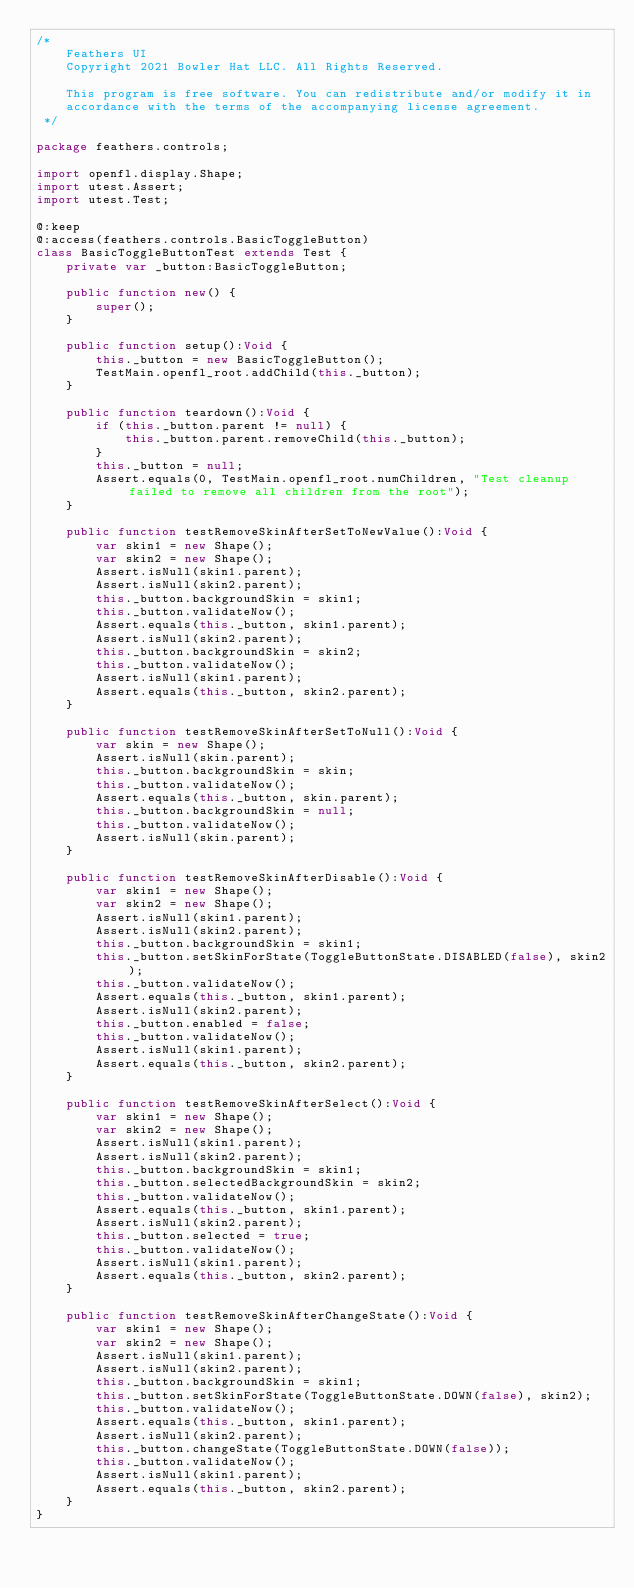<code> <loc_0><loc_0><loc_500><loc_500><_Haxe_>/*
	Feathers UI
	Copyright 2021 Bowler Hat LLC. All Rights Reserved.

	This program is free software. You can redistribute and/or modify it in
	accordance with the terms of the accompanying license agreement.
 */

package feathers.controls;

import openfl.display.Shape;
import utest.Assert;
import utest.Test;

@:keep
@:access(feathers.controls.BasicToggleButton)
class BasicToggleButtonTest extends Test {
	private var _button:BasicToggleButton;

	public function new() {
		super();
	}

	public function setup():Void {
		this._button = new BasicToggleButton();
		TestMain.openfl_root.addChild(this._button);
	}

	public function teardown():Void {
		if (this._button.parent != null) {
			this._button.parent.removeChild(this._button);
		}
		this._button = null;
		Assert.equals(0, TestMain.openfl_root.numChildren, "Test cleanup failed to remove all children from the root");
	}

	public function testRemoveSkinAfterSetToNewValue():Void {
		var skin1 = new Shape();
		var skin2 = new Shape();
		Assert.isNull(skin1.parent);
		Assert.isNull(skin2.parent);
		this._button.backgroundSkin = skin1;
		this._button.validateNow();
		Assert.equals(this._button, skin1.parent);
		Assert.isNull(skin2.parent);
		this._button.backgroundSkin = skin2;
		this._button.validateNow();
		Assert.isNull(skin1.parent);
		Assert.equals(this._button, skin2.parent);
	}

	public function testRemoveSkinAfterSetToNull():Void {
		var skin = new Shape();
		Assert.isNull(skin.parent);
		this._button.backgroundSkin = skin;
		this._button.validateNow();
		Assert.equals(this._button, skin.parent);
		this._button.backgroundSkin = null;
		this._button.validateNow();
		Assert.isNull(skin.parent);
	}

	public function testRemoveSkinAfterDisable():Void {
		var skin1 = new Shape();
		var skin2 = new Shape();
		Assert.isNull(skin1.parent);
		Assert.isNull(skin2.parent);
		this._button.backgroundSkin = skin1;
		this._button.setSkinForState(ToggleButtonState.DISABLED(false), skin2);
		this._button.validateNow();
		Assert.equals(this._button, skin1.parent);
		Assert.isNull(skin2.parent);
		this._button.enabled = false;
		this._button.validateNow();
		Assert.isNull(skin1.parent);
		Assert.equals(this._button, skin2.parent);
	}

	public function testRemoveSkinAfterSelect():Void {
		var skin1 = new Shape();
		var skin2 = new Shape();
		Assert.isNull(skin1.parent);
		Assert.isNull(skin2.parent);
		this._button.backgroundSkin = skin1;
		this._button.selectedBackgroundSkin = skin2;
		this._button.validateNow();
		Assert.equals(this._button, skin1.parent);
		Assert.isNull(skin2.parent);
		this._button.selected = true;
		this._button.validateNow();
		Assert.isNull(skin1.parent);
		Assert.equals(this._button, skin2.parent);
	}

	public function testRemoveSkinAfterChangeState():Void {
		var skin1 = new Shape();
		var skin2 = new Shape();
		Assert.isNull(skin1.parent);
		Assert.isNull(skin2.parent);
		this._button.backgroundSkin = skin1;
		this._button.setSkinForState(ToggleButtonState.DOWN(false), skin2);
		this._button.validateNow();
		Assert.equals(this._button, skin1.parent);
		Assert.isNull(skin2.parent);
		this._button.changeState(ToggleButtonState.DOWN(false));
		this._button.validateNow();
		Assert.isNull(skin1.parent);
		Assert.equals(this._button, skin2.parent);
	}
}
</code> 